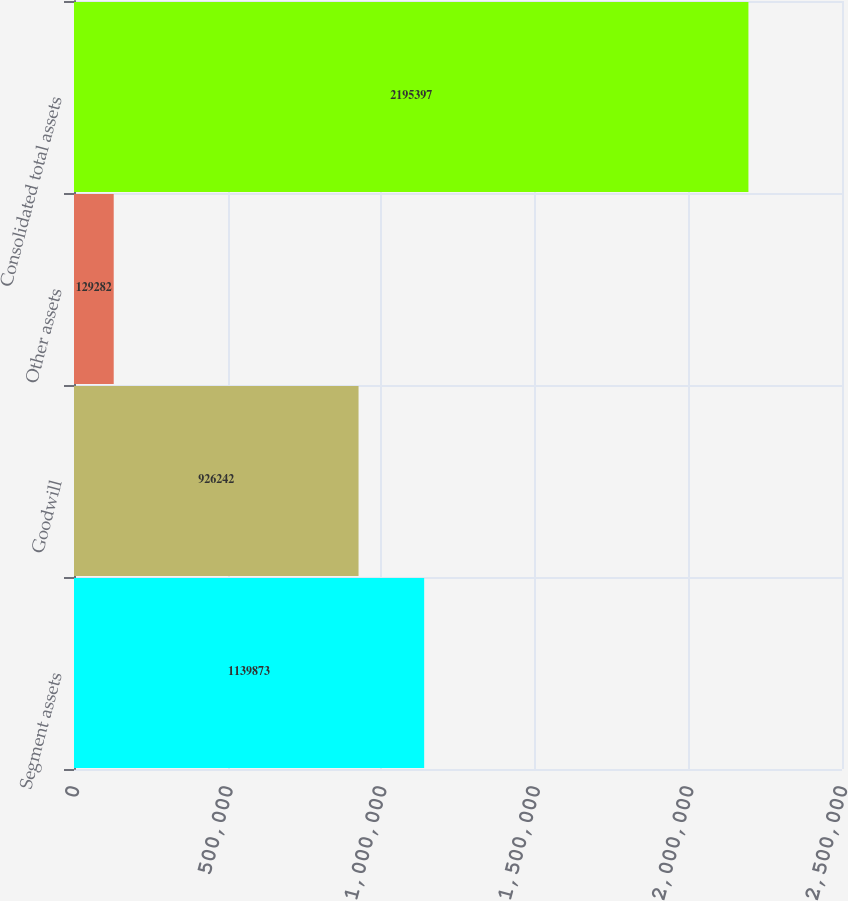<chart> <loc_0><loc_0><loc_500><loc_500><bar_chart><fcel>Segment assets<fcel>Goodwill<fcel>Other assets<fcel>Consolidated total assets<nl><fcel>1.13987e+06<fcel>926242<fcel>129282<fcel>2.1954e+06<nl></chart> 